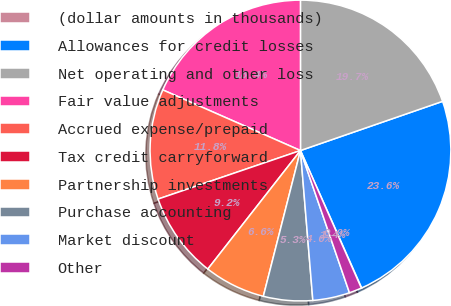Convert chart to OTSL. <chart><loc_0><loc_0><loc_500><loc_500><pie_chart><fcel>(dollar amounts in thousands)<fcel>Allowances for credit losses<fcel>Net operating and other loss<fcel>Fair value adjustments<fcel>Accrued expense/prepaid<fcel>Tax credit carryforward<fcel>Partnership investments<fcel>Purchase accounting<fcel>Market discount<fcel>Other<nl><fcel>0.04%<fcel>23.63%<fcel>19.7%<fcel>18.39%<fcel>11.83%<fcel>9.21%<fcel>6.59%<fcel>5.28%<fcel>3.97%<fcel>1.35%<nl></chart> 